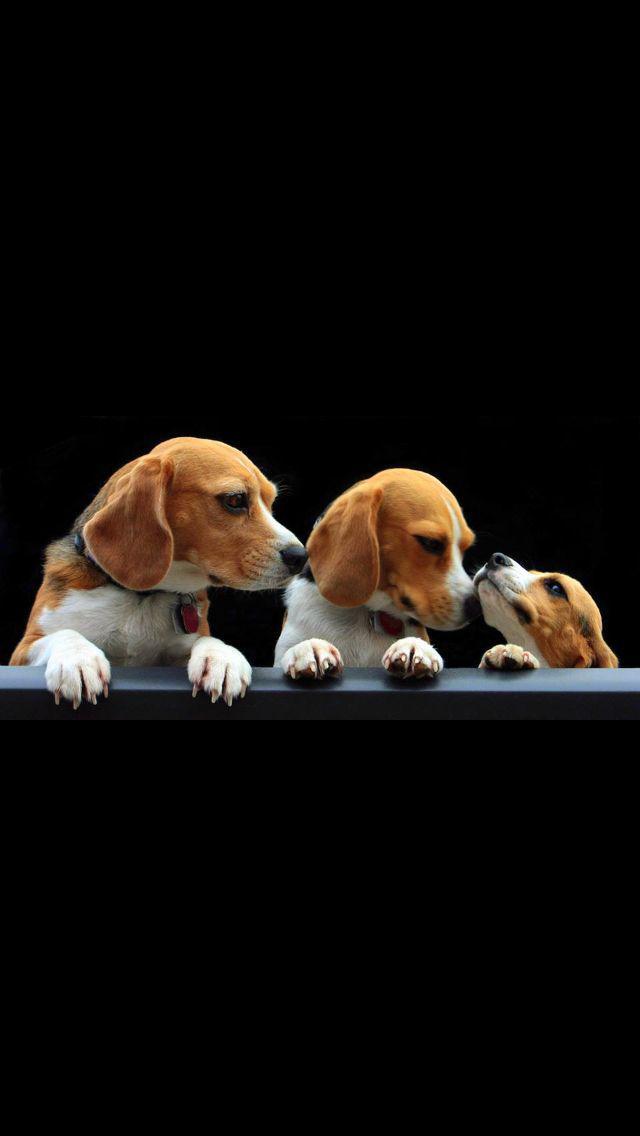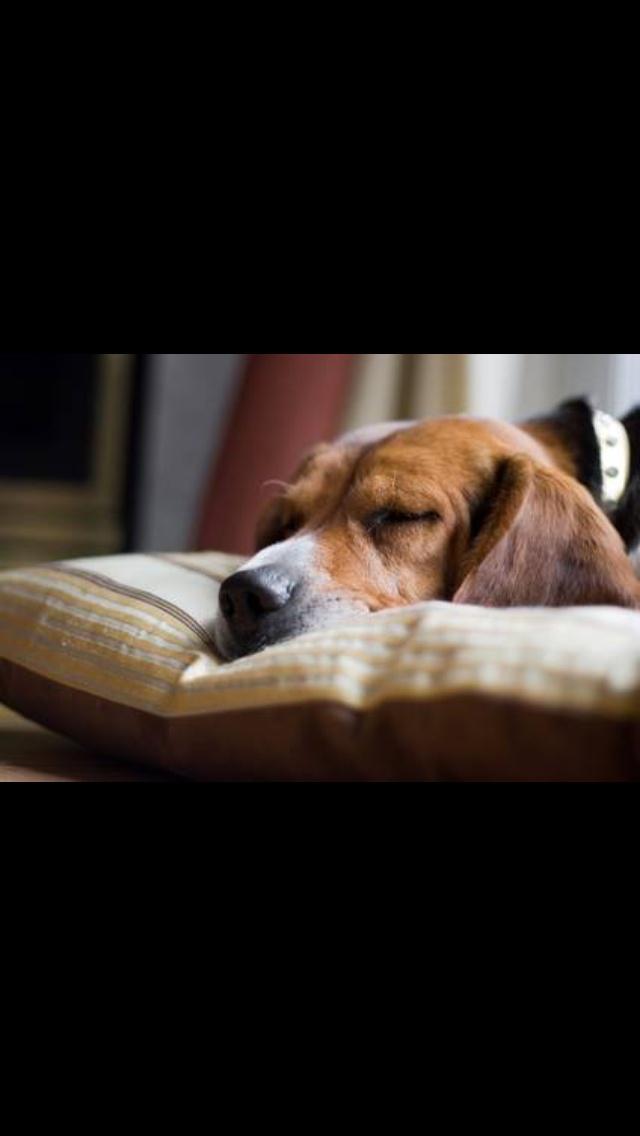The first image is the image on the left, the second image is the image on the right. Given the left and right images, does the statement "Right image shows beagles sleeping in a soft-sided roundish pet bed." hold true? Answer yes or no. No. The first image is the image on the left, the second image is the image on the right. Given the left and right images, does the statement "Two dogs are sleeping together in one of the images." hold true? Answer yes or no. No. 